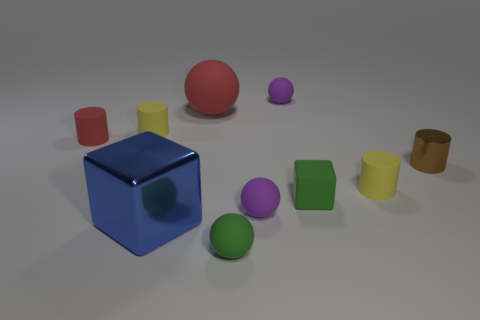Subtract all large red matte spheres. How many spheres are left? 3 Subtract all red cylinders. How many cylinders are left? 3 Subtract all red blocks. How many purple balls are left? 2 Subtract all spheres. How many objects are left? 6 Subtract 2 balls. How many balls are left? 2 Subtract all small red shiny cylinders. Subtract all large metallic cubes. How many objects are left? 9 Add 2 small spheres. How many small spheres are left? 5 Add 7 big red rubber things. How many big red rubber things exist? 8 Subtract 0 gray cubes. How many objects are left? 10 Subtract all cyan blocks. Subtract all blue spheres. How many blocks are left? 2 